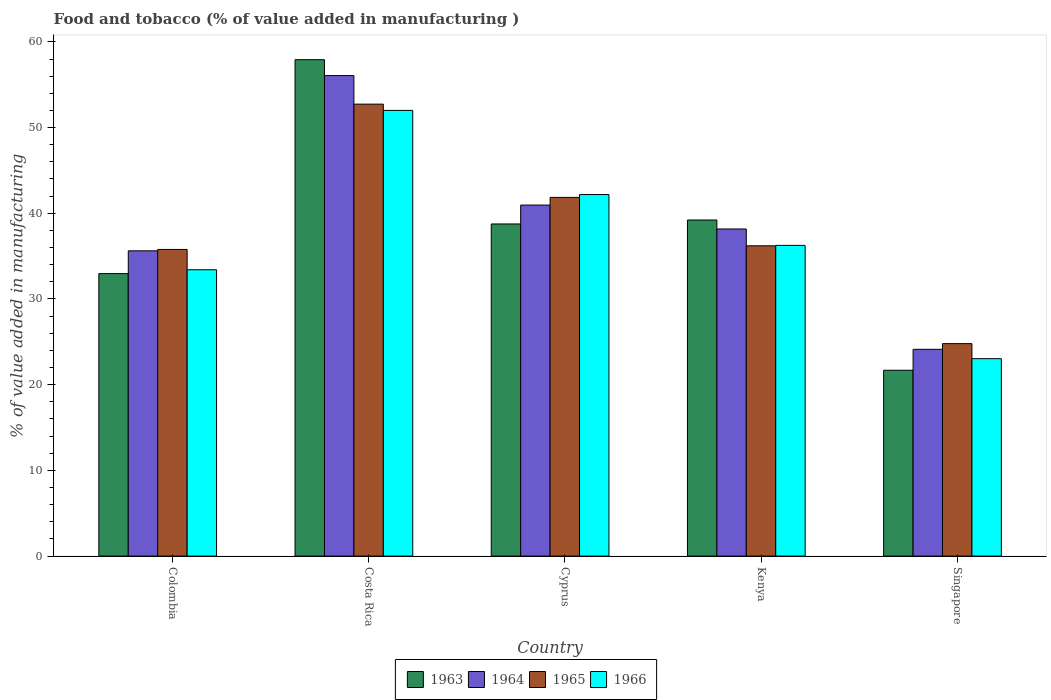How many different coloured bars are there?
Provide a succinct answer. 4. How many groups of bars are there?
Your answer should be very brief. 5. Are the number of bars per tick equal to the number of legend labels?
Your answer should be compact. Yes. Are the number of bars on each tick of the X-axis equal?
Give a very brief answer. Yes. How many bars are there on the 4th tick from the left?
Make the answer very short. 4. How many bars are there on the 1st tick from the right?
Give a very brief answer. 4. What is the label of the 3rd group of bars from the left?
Give a very brief answer. Cyprus. What is the value added in manufacturing food and tobacco in 1966 in Colombia?
Your answer should be very brief. 33.41. Across all countries, what is the maximum value added in manufacturing food and tobacco in 1965?
Provide a short and direct response. 52.73. Across all countries, what is the minimum value added in manufacturing food and tobacco in 1964?
Offer a very short reply. 24.13. In which country was the value added in manufacturing food and tobacco in 1963 minimum?
Your answer should be compact. Singapore. What is the total value added in manufacturing food and tobacco in 1965 in the graph?
Make the answer very short. 191.36. What is the difference between the value added in manufacturing food and tobacco in 1965 in Colombia and that in Kenya?
Your answer should be very brief. -0.42. What is the difference between the value added in manufacturing food and tobacco in 1966 in Singapore and the value added in manufacturing food and tobacco in 1964 in Colombia?
Offer a terse response. -12.58. What is the average value added in manufacturing food and tobacco in 1965 per country?
Ensure brevity in your answer.  38.27. What is the difference between the value added in manufacturing food and tobacco of/in 1964 and value added in manufacturing food and tobacco of/in 1966 in Kenya?
Offer a terse response. 1.91. In how many countries, is the value added in manufacturing food and tobacco in 1963 greater than 38 %?
Offer a terse response. 3. What is the ratio of the value added in manufacturing food and tobacco in 1964 in Cyprus to that in Singapore?
Your answer should be very brief. 1.7. Is the value added in manufacturing food and tobacco in 1963 in Kenya less than that in Singapore?
Your answer should be compact. No. What is the difference between the highest and the second highest value added in manufacturing food and tobacco in 1964?
Give a very brief answer. 15.11. What is the difference between the highest and the lowest value added in manufacturing food and tobacco in 1963?
Ensure brevity in your answer.  36.23. Is the sum of the value added in manufacturing food and tobacco in 1965 in Colombia and Cyprus greater than the maximum value added in manufacturing food and tobacco in 1963 across all countries?
Your answer should be very brief. Yes. What does the 4th bar from the left in Costa Rica represents?
Give a very brief answer. 1966. What does the 4th bar from the right in Kenya represents?
Your answer should be compact. 1963. How many bars are there?
Provide a short and direct response. 20. Are all the bars in the graph horizontal?
Provide a short and direct response. No. What is the difference between two consecutive major ticks on the Y-axis?
Provide a short and direct response. 10. Are the values on the major ticks of Y-axis written in scientific E-notation?
Provide a succinct answer. No. Does the graph contain any zero values?
Keep it short and to the point. No. Does the graph contain grids?
Make the answer very short. No. Where does the legend appear in the graph?
Offer a terse response. Bottom center. How are the legend labels stacked?
Offer a terse response. Horizontal. What is the title of the graph?
Your answer should be very brief. Food and tobacco (% of value added in manufacturing ). What is the label or title of the Y-axis?
Your response must be concise. % of value added in manufacturing. What is the % of value added in manufacturing in 1963 in Colombia?
Your answer should be very brief. 32.96. What is the % of value added in manufacturing in 1964 in Colombia?
Ensure brevity in your answer.  35.62. What is the % of value added in manufacturing of 1965 in Colombia?
Provide a succinct answer. 35.78. What is the % of value added in manufacturing of 1966 in Colombia?
Offer a terse response. 33.41. What is the % of value added in manufacturing of 1963 in Costa Rica?
Offer a very short reply. 57.92. What is the % of value added in manufacturing of 1964 in Costa Rica?
Ensure brevity in your answer.  56.07. What is the % of value added in manufacturing in 1965 in Costa Rica?
Give a very brief answer. 52.73. What is the % of value added in manufacturing of 1966 in Costa Rica?
Your response must be concise. 52. What is the % of value added in manufacturing of 1963 in Cyprus?
Ensure brevity in your answer.  38.75. What is the % of value added in manufacturing of 1964 in Cyprus?
Provide a short and direct response. 40.96. What is the % of value added in manufacturing in 1965 in Cyprus?
Offer a terse response. 41.85. What is the % of value added in manufacturing of 1966 in Cyprus?
Give a very brief answer. 42.19. What is the % of value added in manufacturing of 1963 in Kenya?
Offer a very short reply. 39.22. What is the % of value added in manufacturing in 1964 in Kenya?
Keep it short and to the point. 38.17. What is the % of value added in manufacturing of 1965 in Kenya?
Ensure brevity in your answer.  36.2. What is the % of value added in manufacturing of 1966 in Kenya?
Provide a succinct answer. 36.25. What is the % of value added in manufacturing of 1963 in Singapore?
Your answer should be compact. 21.69. What is the % of value added in manufacturing in 1964 in Singapore?
Offer a very short reply. 24.13. What is the % of value added in manufacturing in 1965 in Singapore?
Keep it short and to the point. 24.79. What is the % of value added in manufacturing of 1966 in Singapore?
Provide a short and direct response. 23.04. Across all countries, what is the maximum % of value added in manufacturing of 1963?
Make the answer very short. 57.92. Across all countries, what is the maximum % of value added in manufacturing of 1964?
Offer a terse response. 56.07. Across all countries, what is the maximum % of value added in manufacturing in 1965?
Your answer should be compact. 52.73. Across all countries, what is the maximum % of value added in manufacturing in 1966?
Make the answer very short. 52. Across all countries, what is the minimum % of value added in manufacturing in 1963?
Offer a terse response. 21.69. Across all countries, what is the minimum % of value added in manufacturing of 1964?
Keep it short and to the point. 24.13. Across all countries, what is the minimum % of value added in manufacturing of 1965?
Offer a terse response. 24.79. Across all countries, what is the minimum % of value added in manufacturing of 1966?
Ensure brevity in your answer.  23.04. What is the total % of value added in manufacturing in 1963 in the graph?
Ensure brevity in your answer.  190.54. What is the total % of value added in manufacturing of 1964 in the graph?
Ensure brevity in your answer.  194.94. What is the total % of value added in manufacturing in 1965 in the graph?
Your answer should be compact. 191.36. What is the total % of value added in manufacturing of 1966 in the graph?
Keep it short and to the point. 186.89. What is the difference between the % of value added in manufacturing of 1963 in Colombia and that in Costa Rica?
Provide a succinct answer. -24.96. What is the difference between the % of value added in manufacturing of 1964 in Colombia and that in Costa Rica?
Ensure brevity in your answer.  -20.45. What is the difference between the % of value added in manufacturing of 1965 in Colombia and that in Costa Rica?
Keep it short and to the point. -16.95. What is the difference between the % of value added in manufacturing in 1966 in Colombia and that in Costa Rica?
Ensure brevity in your answer.  -18.59. What is the difference between the % of value added in manufacturing of 1963 in Colombia and that in Cyprus?
Your response must be concise. -5.79. What is the difference between the % of value added in manufacturing in 1964 in Colombia and that in Cyprus?
Keep it short and to the point. -5.34. What is the difference between the % of value added in manufacturing in 1965 in Colombia and that in Cyprus?
Make the answer very short. -6.07. What is the difference between the % of value added in manufacturing of 1966 in Colombia and that in Cyprus?
Provide a succinct answer. -8.78. What is the difference between the % of value added in manufacturing in 1963 in Colombia and that in Kenya?
Offer a very short reply. -6.26. What is the difference between the % of value added in manufacturing in 1964 in Colombia and that in Kenya?
Your answer should be compact. -2.55. What is the difference between the % of value added in manufacturing of 1965 in Colombia and that in Kenya?
Provide a succinct answer. -0.42. What is the difference between the % of value added in manufacturing of 1966 in Colombia and that in Kenya?
Your response must be concise. -2.84. What is the difference between the % of value added in manufacturing in 1963 in Colombia and that in Singapore?
Your answer should be very brief. 11.27. What is the difference between the % of value added in manufacturing of 1964 in Colombia and that in Singapore?
Make the answer very short. 11.49. What is the difference between the % of value added in manufacturing of 1965 in Colombia and that in Singapore?
Your answer should be very brief. 10.99. What is the difference between the % of value added in manufacturing of 1966 in Colombia and that in Singapore?
Your answer should be compact. 10.37. What is the difference between the % of value added in manufacturing in 1963 in Costa Rica and that in Cyprus?
Your response must be concise. 19.17. What is the difference between the % of value added in manufacturing of 1964 in Costa Rica and that in Cyprus?
Provide a succinct answer. 15.11. What is the difference between the % of value added in manufacturing in 1965 in Costa Rica and that in Cyprus?
Offer a terse response. 10.88. What is the difference between the % of value added in manufacturing of 1966 in Costa Rica and that in Cyprus?
Make the answer very short. 9.82. What is the difference between the % of value added in manufacturing in 1963 in Costa Rica and that in Kenya?
Your response must be concise. 18.7. What is the difference between the % of value added in manufacturing in 1964 in Costa Rica and that in Kenya?
Ensure brevity in your answer.  17.9. What is the difference between the % of value added in manufacturing in 1965 in Costa Rica and that in Kenya?
Your answer should be very brief. 16.53. What is the difference between the % of value added in manufacturing in 1966 in Costa Rica and that in Kenya?
Your response must be concise. 15.75. What is the difference between the % of value added in manufacturing in 1963 in Costa Rica and that in Singapore?
Offer a very short reply. 36.23. What is the difference between the % of value added in manufacturing in 1964 in Costa Rica and that in Singapore?
Make the answer very short. 31.94. What is the difference between the % of value added in manufacturing of 1965 in Costa Rica and that in Singapore?
Give a very brief answer. 27.94. What is the difference between the % of value added in manufacturing of 1966 in Costa Rica and that in Singapore?
Ensure brevity in your answer.  28.97. What is the difference between the % of value added in manufacturing in 1963 in Cyprus and that in Kenya?
Make the answer very short. -0.46. What is the difference between the % of value added in manufacturing in 1964 in Cyprus and that in Kenya?
Your response must be concise. 2.79. What is the difference between the % of value added in manufacturing of 1965 in Cyprus and that in Kenya?
Provide a succinct answer. 5.65. What is the difference between the % of value added in manufacturing in 1966 in Cyprus and that in Kenya?
Provide a succinct answer. 5.93. What is the difference between the % of value added in manufacturing in 1963 in Cyprus and that in Singapore?
Ensure brevity in your answer.  17.07. What is the difference between the % of value added in manufacturing in 1964 in Cyprus and that in Singapore?
Keep it short and to the point. 16.83. What is the difference between the % of value added in manufacturing of 1965 in Cyprus and that in Singapore?
Your answer should be compact. 17.06. What is the difference between the % of value added in manufacturing in 1966 in Cyprus and that in Singapore?
Offer a very short reply. 19.15. What is the difference between the % of value added in manufacturing of 1963 in Kenya and that in Singapore?
Ensure brevity in your answer.  17.53. What is the difference between the % of value added in manufacturing of 1964 in Kenya and that in Singapore?
Provide a short and direct response. 14.04. What is the difference between the % of value added in manufacturing of 1965 in Kenya and that in Singapore?
Provide a succinct answer. 11.41. What is the difference between the % of value added in manufacturing in 1966 in Kenya and that in Singapore?
Keep it short and to the point. 13.22. What is the difference between the % of value added in manufacturing in 1963 in Colombia and the % of value added in manufacturing in 1964 in Costa Rica?
Ensure brevity in your answer.  -23.11. What is the difference between the % of value added in manufacturing of 1963 in Colombia and the % of value added in manufacturing of 1965 in Costa Rica?
Your answer should be compact. -19.77. What is the difference between the % of value added in manufacturing of 1963 in Colombia and the % of value added in manufacturing of 1966 in Costa Rica?
Offer a very short reply. -19.04. What is the difference between the % of value added in manufacturing in 1964 in Colombia and the % of value added in manufacturing in 1965 in Costa Rica?
Provide a short and direct response. -17.11. What is the difference between the % of value added in manufacturing of 1964 in Colombia and the % of value added in manufacturing of 1966 in Costa Rica?
Your response must be concise. -16.38. What is the difference between the % of value added in manufacturing of 1965 in Colombia and the % of value added in manufacturing of 1966 in Costa Rica?
Offer a terse response. -16.22. What is the difference between the % of value added in manufacturing in 1963 in Colombia and the % of value added in manufacturing in 1964 in Cyprus?
Keep it short and to the point. -8. What is the difference between the % of value added in manufacturing of 1963 in Colombia and the % of value added in manufacturing of 1965 in Cyprus?
Provide a short and direct response. -8.89. What is the difference between the % of value added in manufacturing of 1963 in Colombia and the % of value added in manufacturing of 1966 in Cyprus?
Provide a succinct answer. -9.23. What is the difference between the % of value added in manufacturing in 1964 in Colombia and the % of value added in manufacturing in 1965 in Cyprus?
Keep it short and to the point. -6.23. What is the difference between the % of value added in manufacturing in 1964 in Colombia and the % of value added in manufacturing in 1966 in Cyprus?
Offer a very short reply. -6.57. What is the difference between the % of value added in manufacturing in 1965 in Colombia and the % of value added in manufacturing in 1966 in Cyprus?
Make the answer very short. -6.41. What is the difference between the % of value added in manufacturing in 1963 in Colombia and the % of value added in manufacturing in 1964 in Kenya?
Offer a very short reply. -5.21. What is the difference between the % of value added in manufacturing of 1963 in Colombia and the % of value added in manufacturing of 1965 in Kenya?
Your response must be concise. -3.24. What is the difference between the % of value added in manufacturing of 1963 in Colombia and the % of value added in manufacturing of 1966 in Kenya?
Make the answer very short. -3.29. What is the difference between the % of value added in manufacturing of 1964 in Colombia and the % of value added in manufacturing of 1965 in Kenya?
Give a very brief answer. -0.58. What is the difference between the % of value added in manufacturing in 1964 in Colombia and the % of value added in manufacturing in 1966 in Kenya?
Keep it short and to the point. -0.63. What is the difference between the % of value added in manufacturing in 1965 in Colombia and the % of value added in manufacturing in 1966 in Kenya?
Offer a terse response. -0.47. What is the difference between the % of value added in manufacturing in 1963 in Colombia and the % of value added in manufacturing in 1964 in Singapore?
Keep it short and to the point. 8.83. What is the difference between the % of value added in manufacturing of 1963 in Colombia and the % of value added in manufacturing of 1965 in Singapore?
Your answer should be compact. 8.17. What is the difference between the % of value added in manufacturing in 1963 in Colombia and the % of value added in manufacturing in 1966 in Singapore?
Offer a very short reply. 9.92. What is the difference between the % of value added in manufacturing in 1964 in Colombia and the % of value added in manufacturing in 1965 in Singapore?
Offer a terse response. 10.83. What is the difference between the % of value added in manufacturing of 1964 in Colombia and the % of value added in manufacturing of 1966 in Singapore?
Your answer should be very brief. 12.58. What is the difference between the % of value added in manufacturing in 1965 in Colombia and the % of value added in manufacturing in 1966 in Singapore?
Give a very brief answer. 12.74. What is the difference between the % of value added in manufacturing of 1963 in Costa Rica and the % of value added in manufacturing of 1964 in Cyprus?
Your response must be concise. 16.96. What is the difference between the % of value added in manufacturing in 1963 in Costa Rica and the % of value added in manufacturing in 1965 in Cyprus?
Your response must be concise. 16.07. What is the difference between the % of value added in manufacturing of 1963 in Costa Rica and the % of value added in manufacturing of 1966 in Cyprus?
Offer a very short reply. 15.73. What is the difference between the % of value added in manufacturing of 1964 in Costa Rica and the % of value added in manufacturing of 1965 in Cyprus?
Make the answer very short. 14.21. What is the difference between the % of value added in manufacturing of 1964 in Costa Rica and the % of value added in manufacturing of 1966 in Cyprus?
Your response must be concise. 13.88. What is the difference between the % of value added in manufacturing in 1965 in Costa Rica and the % of value added in manufacturing in 1966 in Cyprus?
Give a very brief answer. 10.55. What is the difference between the % of value added in manufacturing in 1963 in Costa Rica and the % of value added in manufacturing in 1964 in Kenya?
Give a very brief answer. 19.75. What is the difference between the % of value added in manufacturing of 1963 in Costa Rica and the % of value added in manufacturing of 1965 in Kenya?
Your answer should be compact. 21.72. What is the difference between the % of value added in manufacturing of 1963 in Costa Rica and the % of value added in manufacturing of 1966 in Kenya?
Make the answer very short. 21.67. What is the difference between the % of value added in manufacturing of 1964 in Costa Rica and the % of value added in manufacturing of 1965 in Kenya?
Keep it short and to the point. 19.86. What is the difference between the % of value added in manufacturing in 1964 in Costa Rica and the % of value added in manufacturing in 1966 in Kenya?
Offer a very short reply. 19.81. What is the difference between the % of value added in manufacturing in 1965 in Costa Rica and the % of value added in manufacturing in 1966 in Kenya?
Your answer should be very brief. 16.48. What is the difference between the % of value added in manufacturing in 1963 in Costa Rica and the % of value added in manufacturing in 1964 in Singapore?
Offer a very short reply. 33.79. What is the difference between the % of value added in manufacturing of 1963 in Costa Rica and the % of value added in manufacturing of 1965 in Singapore?
Give a very brief answer. 33.13. What is the difference between the % of value added in manufacturing of 1963 in Costa Rica and the % of value added in manufacturing of 1966 in Singapore?
Keep it short and to the point. 34.88. What is the difference between the % of value added in manufacturing in 1964 in Costa Rica and the % of value added in manufacturing in 1965 in Singapore?
Ensure brevity in your answer.  31.28. What is the difference between the % of value added in manufacturing of 1964 in Costa Rica and the % of value added in manufacturing of 1966 in Singapore?
Offer a very short reply. 33.03. What is the difference between the % of value added in manufacturing of 1965 in Costa Rica and the % of value added in manufacturing of 1966 in Singapore?
Provide a short and direct response. 29.7. What is the difference between the % of value added in manufacturing of 1963 in Cyprus and the % of value added in manufacturing of 1964 in Kenya?
Offer a terse response. 0.59. What is the difference between the % of value added in manufacturing in 1963 in Cyprus and the % of value added in manufacturing in 1965 in Kenya?
Your answer should be very brief. 2.55. What is the difference between the % of value added in manufacturing of 1963 in Cyprus and the % of value added in manufacturing of 1966 in Kenya?
Keep it short and to the point. 2.5. What is the difference between the % of value added in manufacturing in 1964 in Cyprus and the % of value added in manufacturing in 1965 in Kenya?
Provide a succinct answer. 4.75. What is the difference between the % of value added in manufacturing in 1964 in Cyprus and the % of value added in manufacturing in 1966 in Kenya?
Your answer should be very brief. 4.7. What is the difference between the % of value added in manufacturing in 1965 in Cyprus and the % of value added in manufacturing in 1966 in Kenya?
Ensure brevity in your answer.  5.6. What is the difference between the % of value added in manufacturing of 1963 in Cyprus and the % of value added in manufacturing of 1964 in Singapore?
Provide a short and direct response. 14.63. What is the difference between the % of value added in manufacturing in 1963 in Cyprus and the % of value added in manufacturing in 1965 in Singapore?
Your answer should be very brief. 13.96. What is the difference between the % of value added in manufacturing in 1963 in Cyprus and the % of value added in manufacturing in 1966 in Singapore?
Offer a terse response. 15.72. What is the difference between the % of value added in manufacturing of 1964 in Cyprus and the % of value added in manufacturing of 1965 in Singapore?
Provide a short and direct response. 16.17. What is the difference between the % of value added in manufacturing of 1964 in Cyprus and the % of value added in manufacturing of 1966 in Singapore?
Provide a succinct answer. 17.92. What is the difference between the % of value added in manufacturing in 1965 in Cyprus and the % of value added in manufacturing in 1966 in Singapore?
Keep it short and to the point. 18.82. What is the difference between the % of value added in manufacturing in 1963 in Kenya and the % of value added in manufacturing in 1964 in Singapore?
Ensure brevity in your answer.  15.09. What is the difference between the % of value added in manufacturing of 1963 in Kenya and the % of value added in manufacturing of 1965 in Singapore?
Make the answer very short. 14.43. What is the difference between the % of value added in manufacturing of 1963 in Kenya and the % of value added in manufacturing of 1966 in Singapore?
Your answer should be very brief. 16.18. What is the difference between the % of value added in manufacturing of 1964 in Kenya and the % of value added in manufacturing of 1965 in Singapore?
Keep it short and to the point. 13.38. What is the difference between the % of value added in manufacturing in 1964 in Kenya and the % of value added in manufacturing in 1966 in Singapore?
Offer a terse response. 15.13. What is the difference between the % of value added in manufacturing in 1965 in Kenya and the % of value added in manufacturing in 1966 in Singapore?
Offer a terse response. 13.17. What is the average % of value added in manufacturing of 1963 per country?
Your response must be concise. 38.11. What is the average % of value added in manufacturing in 1964 per country?
Your answer should be very brief. 38.99. What is the average % of value added in manufacturing of 1965 per country?
Keep it short and to the point. 38.27. What is the average % of value added in manufacturing of 1966 per country?
Your response must be concise. 37.38. What is the difference between the % of value added in manufacturing of 1963 and % of value added in manufacturing of 1964 in Colombia?
Give a very brief answer. -2.66. What is the difference between the % of value added in manufacturing in 1963 and % of value added in manufacturing in 1965 in Colombia?
Ensure brevity in your answer.  -2.82. What is the difference between the % of value added in manufacturing in 1963 and % of value added in manufacturing in 1966 in Colombia?
Provide a short and direct response. -0.45. What is the difference between the % of value added in manufacturing in 1964 and % of value added in manufacturing in 1965 in Colombia?
Provide a succinct answer. -0.16. What is the difference between the % of value added in manufacturing of 1964 and % of value added in manufacturing of 1966 in Colombia?
Provide a short and direct response. 2.21. What is the difference between the % of value added in manufacturing in 1965 and % of value added in manufacturing in 1966 in Colombia?
Ensure brevity in your answer.  2.37. What is the difference between the % of value added in manufacturing in 1963 and % of value added in manufacturing in 1964 in Costa Rica?
Your answer should be compact. 1.85. What is the difference between the % of value added in manufacturing in 1963 and % of value added in manufacturing in 1965 in Costa Rica?
Your answer should be compact. 5.19. What is the difference between the % of value added in manufacturing in 1963 and % of value added in manufacturing in 1966 in Costa Rica?
Offer a terse response. 5.92. What is the difference between the % of value added in manufacturing in 1964 and % of value added in manufacturing in 1965 in Costa Rica?
Offer a terse response. 3.33. What is the difference between the % of value added in manufacturing in 1964 and % of value added in manufacturing in 1966 in Costa Rica?
Provide a succinct answer. 4.06. What is the difference between the % of value added in manufacturing of 1965 and % of value added in manufacturing of 1966 in Costa Rica?
Offer a terse response. 0.73. What is the difference between the % of value added in manufacturing in 1963 and % of value added in manufacturing in 1964 in Cyprus?
Offer a very short reply. -2.2. What is the difference between the % of value added in manufacturing in 1963 and % of value added in manufacturing in 1965 in Cyprus?
Make the answer very short. -3.1. What is the difference between the % of value added in manufacturing of 1963 and % of value added in manufacturing of 1966 in Cyprus?
Provide a short and direct response. -3.43. What is the difference between the % of value added in manufacturing in 1964 and % of value added in manufacturing in 1965 in Cyprus?
Ensure brevity in your answer.  -0.9. What is the difference between the % of value added in manufacturing of 1964 and % of value added in manufacturing of 1966 in Cyprus?
Your answer should be very brief. -1.23. What is the difference between the % of value added in manufacturing in 1965 and % of value added in manufacturing in 1966 in Cyprus?
Ensure brevity in your answer.  -0.33. What is the difference between the % of value added in manufacturing of 1963 and % of value added in manufacturing of 1964 in Kenya?
Keep it short and to the point. 1.05. What is the difference between the % of value added in manufacturing in 1963 and % of value added in manufacturing in 1965 in Kenya?
Give a very brief answer. 3.01. What is the difference between the % of value added in manufacturing in 1963 and % of value added in manufacturing in 1966 in Kenya?
Offer a terse response. 2.96. What is the difference between the % of value added in manufacturing in 1964 and % of value added in manufacturing in 1965 in Kenya?
Ensure brevity in your answer.  1.96. What is the difference between the % of value added in manufacturing of 1964 and % of value added in manufacturing of 1966 in Kenya?
Your response must be concise. 1.91. What is the difference between the % of value added in manufacturing in 1963 and % of value added in manufacturing in 1964 in Singapore?
Offer a very short reply. -2.44. What is the difference between the % of value added in manufacturing in 1963 and % of value added in manufacturing in 1965 in Singapore?
Your response must be concise. -3.1. What is the difference between the % of value added in manufacturing in 1963 and % of value added in manufacturing in 1966 in Singapore?
Give a very brief answer. -1.35. What is the difference between the % of value added in manufacturing of 1964 and % of value added in manufacturing of 1965 in Singapore?
Ensure brevity in your answer.  -0.66. What is the difference between the % of value added in manufacturing of 1964 and % of value added in manufacturing of 1966 in Singapore?
Offer a very short reply. 1.09. What is the difference between the % of value added in manufacturing in 1965 and % of value added in manufacturing in 1966 in Singapore?
Offer a very short reply. 1.75. What is the ratio of the % of value added in manufacturing in 1963 in Colombia to that in Costa Rica?
Ensure brevity in your answer.  0.57. What is the ratio of the % of value added in manufacturing in 1964 in Colombia to that in Costa Rica?
Your answer should be compact. 0.64. What is the ratio of the % of value added in manufacturing in 1965 in Colombia to that in Costa Rica?
Make the answer very short. 0.68. What is the ratio of the % of value added in manufacturing of 1966 in Colombia to that in Costa Rica?
Your response must be concise. 0.64. What is the ratio of the % of value added in manufacturing of 1963 in Colombia to that in Cyprus?
Ensure brevity in your answer.  0.85. What is the ratio of the % of value added in manufacturing in 1964 in Colombia to that in Cyprus?
Give a very brief answer. 0.87. What is the ratio of the % of value added in manufacturing in 1965 in Colombia to that in Cyprus?
Keep it short and to the point. 0.85. What is the ratio of the % of value added in manufacturing of 1966 in Colombia to that in Cyprus?
Offer a terse response. 0.79. What is the ratio of the % of value added in manufacturing in 1963 in Colombia to that in Kenya?
Make the answer very short. 0.84. What is the ratio of the % of value added in manufacturing of 1964 in Colombia to that in Kenya?
Offer a very short reply. 0.93. What is the ratio of the % of value added in manufacturing of 1965 in Colombia to that in Kenya?
Your answer should be compact. 0.99. What is the ratio of the % of value added in manufacturing of 1966 in Colombia to that in Kenya?
Provide a short and direct response. 0.92. What is the ratio of the % of value added in manufacturing of 1963 in Colombia to that in Singapore?
Ensure brevity in your answer.  1.52. What is the ratio of the % of value added in manufacturing of 1964 in Colombia to that in Singapore?
Offer a very short reply. 1.48. What is the ratio of the % of value added in manufacturing of 1965 in Colombia to that in Singapore?
Provide a succinct answer. 1.44. What is the ratio of the % of value added in manufacturing of 1966 in Colombia to that in Singapore?
Provide a succinct answer. 1.45. What is the ratio of the % of value added in manufacturing of 1963 in Costa Rica to that in Cyprus?
Make the answer very short. 1.49. What is the ratio of the % of value added in manufacturing of 1964 in Costa Rica to that in Cyprus?
Keep it short and to the point. 1.37. What is the ratio of the % of value added in manufacturing in 1965 in Costa Rica to that in Cyprus?
Offer a very short reply. 1.26. What is the ratio of the % of value added in manufacturing of 1966 in Costa Rica to that in Cyprus?
Your response must be concise. 1.23. What is the ratio of the % of value added in manufacturing in 1963 in Costa Rica to that in Kenya?
Ensure brevity in your answer.  1.48. What is the ratio of the % of value added in manufacturing of 1964 in Costa Rica to that in Kenya?
Your response must be concise. 1.47. What is the ratio of the % of value added in manufacturing in 1965 in Costa Rica to that in Kenya?
Make the answer very short. 1.46. What is the ratio of the % of value added in manufacturing of 1966 in Costa Rica to that in Kenya?
Give a very brief answer. 1.43. What is the ratio of the % of value added in manufacturing in 1963 in Costa Rica to that in Singapore?
Offer a terse response. 2.67. What is the ratio of the % of value added in manufacturing in 1964 in Costa Rica to that in Singapore?
Provide a succinct answer. 2.32. What is the ratio of the % of value added in manufacturing of 1965 in Costa Rica to that in Singapore?
Your answer should be very brief. 2.13. What is the ratio of the % of value added in manufacturing in 1966 in Costa Rica to that in Singapore?
Offer a very short reply. 2.26. What is the ratio of the % of value added in manufacturing of 1964 in Cyprus to that in Kenya?
Make the answer very short. 1.07. What is the ratio of the % of value added in manufacturing in 1965 in Cyprus to that in Kenya?
Your answer should be very brief. 1.16. What is the ratio of the % of value added in manufacturing of 1966 in Cyprus to that in Kenya?
Give a very brief answer. 1.16. What is the ratio of the % of value added in manufacturing of 1963 in Cyprus to that in Singapore?
Give a very brief answer. 1.79. What is the ratio of the % of value added in manufacturing in 1964 in Cyprus to that in Singapore?
Offer a very short reply. 1.7. What is the ratio of the % of value added in manufacturing of 1965 in Cyprus to that in Singapore?
Offer a very short reply. 1.69. What is the ratio of the % of value added in manufacturing in 1966 in Cyprus to that in Singapore?
Give a very brief answer. 1.83. What is the ratio of the % of value added in manufacturing of 1963 in Kenya to that in Singapore?
Give a very brief answer. 1.81. What is the ratio of the % of value added in manufacturing of 1964 in Kenya to that in Singapore?
Make the answer very short. 1.58. What is the ratio of the % of value added in manufacturing of 1965 in Kenya to that in Singapore?
Keep it short and to the point. 1.46. What is the ratio of the % of value added in manufacturing of 1966 in Kenya to that in Singapore?
Offer a very short reply. 1.57. What is the difference between the highest and the second highest % of value added in manufacturing in 1963?
Your answer should be compact. 18.7. What is the difference between the highest and the second highest % of value added in manufacturing of 1964?
Provide a short and direct response. 15.11. What is the difference between the highest and the second highest % of value added in manufacturing of 1965?
Ensure brevity in your answer.  10.88. What is the difference between the highest and the second highest % of value added in manufacturing of 1966?
Provide a succinct answer. 9.82. What is the difference between the highest and the lowest % of value added in manufacturing of 1963?
Keep it short and to the point. 36.23. What is the difference between the highest and the lowest % of value added in manufacturing in 1964?
Give a very brief answer. 31.94. What is the difference between the highest and the lowest % of value added in manufacturing of 1965?
Offer a terse response. 27.94. What is the difference between the highest and the lowest % of value added in manufacturing in 1966?
Your answer should be compact. 28.97. 